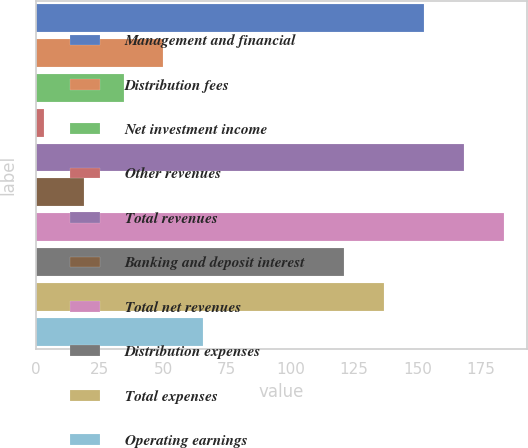Convert chart to OTSL. <chart><loc_0><loc_0><loc_500><loc_500><bar_chart><fcel>Management and financial<fcel>Distribution fees<fcel>Net investment income<fcel>Other revenues<fcel>Total revenues<fcel>Banking and deposit interest<fcel>Total net revenues<fcel>Distribution expenses<fcel>Total expenses<fcel>Operating earnings<nl><fcel>152.4<fcel>50.1<fcel>34.4<fcel>3<fcel>168.1<fcel>18.7<fcel>183.8<fcel>121<fcel>136.7<fcel>65.8<nl></chart> 